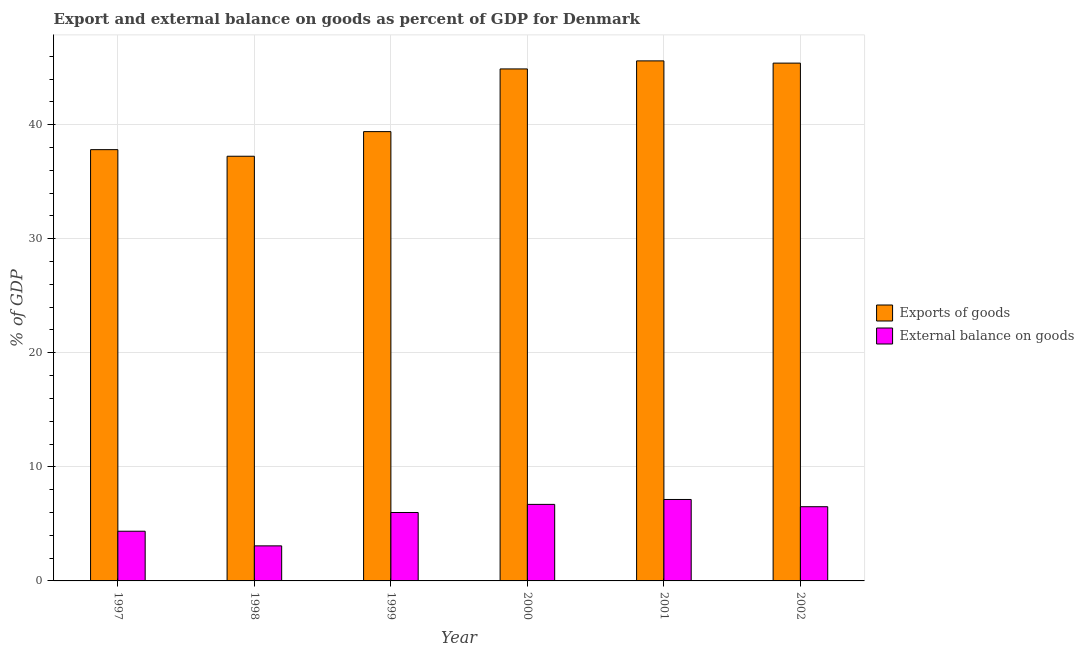How many different coloured bars are there?
Give a very brief answer. 2. How many groups of bars are there?
Make the answer very short. 6. Are the number of bars on each tick of the X-axis equal?
Your answer should be compact. Yes. How many bars are there on the 3rd tick from the left?
Give a very brief answer. 2. How many bars are there on the 2nd tick from the right?
Provide a succinct answer. 2. What is the external balance on goods as percentage of gdp in 1999?
Provide a short and direct response. 6. Across all years, what is the maximum export of goods as percentage of gdp?
Make the answer very short. 45.6. Across all years, what is the minimum external balance on goods as percentage of gdp?
Your answer should be compact. 3.07. In which year was the external balance on goods as percentage of gdp maximum?
Offer a terse response. 2001. What is the total external balance on goods as percentage of gdp in the graph?
Ensure brevity in your answer.  33.79. What is the difference between the export of goods as percentage of gdp in 1999 and that in 2001?
Make the answer very short. -6.2. What is the difference between the external balance on goods as percentage of gdp in 1997 and the export of goods as percentage of gdp in 1999?
Provide a short and direct response. -1.64. What is the average export of goods as percentage of gdp per year?
Offer a very short reply. 41.72. In the year 2001, what is the difference between the external balance on goods as percentage of gdp and export of goods as percentage of gdp?
Your response must be concise. 0. What is the ratio of the export of goods as percentage of gdp in 1997 to that in 1998?
Your answer should be compact. 1.02. Is the export of goods as percentage of gdp in 1997 less than that in 1998?
Provide a succinct answer. No. Is the difference between the external balance on goods as percentage of gdp in 1997 and 1998 greater than the difference between the export of goods as percentage of gdp in 1997 and 1998?
Keep it short and to the point. No. What is the difference between the highest and the second highest export of goods as percentage of gdp?
Offer a very short reply. 0.2. What is the difference between the highest and the lowest external balance on goods as percentage of gdp?
Offer a terse response. 4.07. What does the 1st bar from the left in 2001 represents?
Offer a terse response. Exports of goods. What does the 1st bar from the right in 2002 represents?
Make the answer very short. External balance on goods. How many bars are there?
Your answer should be very brief. 12. Are all the bars in the graph horizontal?
Your response must be concise. No. Does the graph contain any zero values?
Provide a succinct answer. No. How many legend labels are there?
Your answer should be very brief. 2. How are the legend labels stacked?
Offer a terse response. Vertical. What is the title of the graph?
Give a very brief answer. Export and external balance on goods as percent of GDP for Denmark. Does "Methane emissions" appear as one of the legend labels in the graph?
Provide a short and direct response. No. What is the label or title of the Y-axis?
Keep it short and to the point. % of GDP. What is the % of GDP of Exports of goods in 1997?
Provide a succinct answer. 37.81. What is the % of GDP in External balance on goods in 1997?
Ensure brevity in your answer.  4.36. What is the % of GDP of Exports of goods in 1998?
Make the answer very short. 37.23. What is the % of GDP of External balance on goods in 1998?
Provide a succinct answer. 3.07. What is the % of GDP of Exports of goods in 1999?
Offer a very short reply. 39.39. What is the % of GDP in External balance on goods in 1999?
Offer a very short reply. 6. What is the % of GDP in Exports of goods in 2000?
Ensure brevity in your answer.  44.89. What is the % of GDP in External balance on goods in 2000?
Offer a terse response. 6.71. What is the % of GDP in Exports of goods in 2001?
Give a very brief answer. 45.6. What is the % of GDP of External balance on goods in 2001?
Your answer should be compact. 7.14. What is the % of GDP in Exports of goods in 2002?
Give a very brief answer. 45.4. What is the % of GDP in External balance on goods in 2002?
Offer a very short reply. 6.51. Across all years, what is the maximum % of GDP in Exports of goods?
Provide a succinct answer. 45.6. Across all years, what is the maximum % of GDP of External balance on goods?
Give a very brief answer. 7.14. Across all years, what is the minimum % of GDP of Exports of goods?
Offer a very short reply. 37.23. Across all years, what is the minimum % of GDP in External balance on goods?
Provide a succinct answer. 3.07. What is the total % of GDP in Exports of goods in the graph?
Your answer should be compact. 250.32. What is the total % of GDP in External balance on goods in the graph?
Make the answer very short. 33.79. What is the difference between the % of GDP in Exports of goods in 1997 and that in 1998?
Your answer should be compact. 0.58. What is the difference between the % of GDP in External balance on goods in 1997 and that in 1998?
Offer a terse response. 1.28. What is the difference between the % of GDP of Exports of goods in 1997 and that in 1999?
Ensure brevity in your answer.  -1.58. What is the difference between the % of GDP in External balance on goods in 1997 and that in 1999?
Give a very brief answer. -1.64. What is the difference between the % of GDP in Exports of goods in 1997 and that in 2000?
Your answer should be very brief. -7.08. What is the difference between the % of GDP in External balance on goods in 1997 and that in 2000?
Your response must be concise. -2.35. What is the difference between the % of GDP in Exports of goods in 1997 and that in 2001?
Your answer should be very brief. -7.78. What is the difference between the % of GDP of External balance on goods in 1997 and that in 2001?
Your answer should be compact. -2.78. What is the difference between the % of GDP in Exports of goods in 1997 and that in 2002?
Offer a terse response. -7.59. What is the difference between the % of GDP of External balance on goods in 1997 and that in 2002?
Offer a very short reply. -2.15. What is the difference between the % of GDP of Exports of goods in 1998 and that in 1999?
Keep it short and to the point. -2.16. What is the difference between the % of GDP in External balance on goods in 1998 and that in 1999?
Give a very brief answer. -2.93. What is the difference between the % of GDP of Exports of goods in 1998 and that in 2000?
Offer a terse response. -7.66. What is the difference between the % of GDP of External balance on goods in 1998 and that in 2000?
Offer a terse response. -3.64. What is the difference between the % of GDP of Exports of goods in 1998 and that in 2001?
Provide a succinct answer. -8.36. What is the difference between the % of GDP of External balance on goods in 1998 and that in 2001?
Your answer should be very brief. -4.07. What is the difference between the % of GDP of Exports of goods in 1998 and that in 2002?
Ensure brevity in your answer.  -8.16. What is the difference between the % of GDP of External balance on goods in 1998 and that in 2002?
Offer a terse response. -3.43. What is the difference between the % of GDP in Exports of goods in 1999 and that in 2000?
Provide a short and direct response. -5.5. What is the difference between the % of GDP of External balance on goods in 1999 and that in 2000?
Provide a short and direct response. -0.71. What is the difference between the % of GDP in Exports of goods in 1999 and that in 2001?
Ensure brevity in your answer.  -6.2. What is the difference between the % of GDP in External balance on goods in 1999 and that in 2001?
Give a very brief answer. -1.14. What is the difference between the % of GDP in Exports of goods in 1999 and that in 2002?
Keep it short and to the point. -6. What is the difference between the % of GDP of External balance on goods in 1999 and that in 2002?
Offer a very short reply. -0.51. What is the difference between the % of GDP of Exports of goods in 2000 and that in 2001?
Keep it short and to the point. -0.71. What is the difference between the % of GDP of External balance on goods in 2000 and that in 2001?
Your answer should be very brief. -0.43. What is the difference between the % of GDP of Exports of goods in 2000 and that in 2002?
Provide a short and direct response. -0.51. What is the difference between the % of GDP in External balance on goods in 2000 and that in 2002?
Ensure brevity in your answer.  0.2. What is the difference between the % of GDP in Exports of goods in 2001 and that in 2002?
Make the answer very short. 0.2. What is the difference between the % of GDP in External balance on goods in 2001 and that in 2002?
Your answer should be very brief. 0.63. What is the difference between the % of GDP in Exports of goods in 1997 and the % of GDP in External balance on goods in 1998?
Offer a very short reply. 34.74. What is the difference between the % of GDP in Exports of goods in 1997 and the % of GDP in External balance on goods in 1999?
Keep it short and to the point. 31.81. What is the difference between the % of GDP in Exports of goods in 1997 and the % of GDP in External balance on goods in 2000?
Your answer should be compact. 31.1. What is the difference between the % of GDP in Exports of goods in 1997 and the % of GDP in External balance on goods in 2001?
Give a very brief answer. 30.67. What is the difference between the % of GDP of Exports of goods in 1997 and the % of GDP of External balance on goods in 2002?
Provide a short and direct response. 31.31. What is the difference between the % of GDP in Exports of goods in 1998 and the % of GDP in External balance on goods in 1999?
Provide a short and direct response. 31.23. What is the difference between the % of GDP in Exports of goods in 1998 and the % of GDP in External balance on goods in 2000?
Offer a very short reply. 30.52. What is the difference between the % of GDP in Exports of goods in 1998 and the % of GDP in External balance on goods in 2001?
Provide a short and direct response. 30.09. What is the difference between the % of GDP in Exports of goods in 1998 and the % of GDP in External balance on goods in 2002?
Offer a very short reply. 30.73. What is the difference between the % of GDP of Exports of goods in 1999 and the % of GDP of External balance on goods in 2000?
Your answer should be very brief. 32.68. What is the difference between the % of GDP in Exports of goods in 1999 and the % of GDP in External balance on goods in 2001?
Ensure brevity in your answer.  32.25. What is the difference between the % of GDP of Exports of goods in 1999 and the % of GDP of External balance on goods in 2002?
Provide a succinct answer. 32.89. What is the difference between the % of GDP in Exports of goods in 2000 and the % of GDP in External balance on goods in 2001?
Your answer should be compact. 37.75. What is the difference between the % of GDP in Exports of goods in 2000 and the % of GDP in External balance on goods in 2002?
Keep it short and to the point. 38.38. What is the difference between the % of GDP of Exports of goods in 2001 and the % of GDP of External balance on goods in 2002?
Offer a very short reply. 39.09. What is the average % of GDP in Exports of goods per year?
Give a very brief answer. 41.72. What is the average % of GDP of External balance on goods per year?
Your answer should be very brief. 5.63. In the year 1997, what is the difference between the % of GDP of Exports of goods and % of GDP of External balance on goods?
Make the answer very short. 33.45. In the year 1998, what is the difference between the % of GDP of Exports of goods and % of GDP of External balance on goods?
Ensure brevity in your answer.  34.16. In the year 1999, what is the difference between the % of GDP of Exports of goods and % of GDP of External balance on goods?
Keep it short and to the point. 33.39. In the year 2000, what is the difference between the % of GDP in Exports of goods and % of GDP in External balance on goods?
Keep it short and to the point. 38.18. In the year 2001, what is the difference between the % of GDP in Exports of goods and % of GDP in External balance on goods?
Keep it short and to the point. 38.45. In the year 2002, what is the difference between the % of GDP of Exports of goods and % of GDP of External balance on goods?
Make the answer very short. 38.89. What is the ratio of the % of GDP of Exports of goods in 1997 to that in 1998?
Your answer should be compact. 1.02. What is the ratio of the % of GDP in External balance on goods in 1997 to that in 1998?
Your answer should be very brief. 1.42. What is the ratio of the % of GDP of Exports of goods in 1997 to that in 1999?
Your answer should be compact. 0.96. What is the ratio of the % of GDP in External balance on goods in 1997 to that in 1999?
Keep it short and to the point. 0.73. What is the ratio of the % of GDP of Exports of goods in 1997 to that in 2000?
Your answer should be compact. 0.84. What is the ratio of the % of GDP of External balance on goods in 1997 to that in 2000?
Give a very brief answer. 0.65. What is the ratio of the % of GDP in Exports of goods in 1997 to that in 2001?
Your response must be concise. 0.83. What is the ratio of the % of GDP of External balance on goods in 1997 to that in 2001?
Your response must be concise. 0.61. What is the ratio of the % of GDP of Exports of goods in 1997 to that in 2002?
Give a very brief answer. 0.83. What is the ratio of the % of GDP in External balance on goods in 1997 to that in 2002?
Make the answer very short. 0.67. What is the ratio of the % of GDP in Exports of goods in 1998 to that in 1999?
Give a very brief answer. 0.95. What is the ratio of the % of GDP of External balance on goods in 1998 to that in 1999?
Keep it short and to the point. 0.51. What is the ratio of the % of GDP in Exports of goods in 1998 to that in 2000?
Offer a terse response. 0.83. What is the ratio of the % of GDP of External balance on goods in 1998 to that in 2000?
Keep it short and to the point. 0.46. What is the ratio of the % of GDP of Exports of goods in 1998 to that in 2001?
Ensure brevity in your answer.  0.82. What is the ratio of the % of GDP of External balance on goods in 1998 to that in 2001?
Your answer should be compact. 0.43. What is the ratio of the % of GDP in Exports of goods in 1998 to that in 2002?
Offer a very short reply. 0.82. What is the ratio of the % of GDP in External balance on goods in 1998 to that in 2002?
Provide a succinct answer. 0.47. What is the ratio of the % of GDP of Exports of goods in 1999 to that in 2000?
Give a very brief answer. 0.88. What is the ratio of the % of GDP of External balance on goods in 1999 to that in 2000?
Your response must be concise. 0.89. What is the ratio of the % of GDP in Exports of goods in 1999 to that in 2001?
Provide a short and direct response. 0.86. What is the ratio of the % of GDP of External balance on goods in 1999 to that in 2001?
Your response must be concise. 0.84. What is the ratio of the % of GDP of Exports of goods in 1999 to that in 2002?
Offer a very short reply. 0.87. What is the ratio of the % of GDP in External balance on goods in 1999 to that in 2002?
Make the answer very short. 0.92. What is the ratio of the % of GDP of Exports of goods in 2000 to that in 2001?
Provide a short and direct response. 0.98. What is the ratio of the % of GDP of External balance on goods in 2000 to that in 2001?
Provide a short and direct response. 0.94. What is the ratio of the % of GDP in External balance on goods in 2000 to that in 2002?
Make the answer very short. 1.03. What is the ratio of the % of GDP in Exports of goods in 2001 to that in 2002?
Your answer should be compact. 1. What is the ratio of the % of GDP of External balance on goods in 2001 to that in 2002?
Ensure brevity in your answer.  1.1. What is the difference between the highest and the second highest % of GDP of Exports of goods?
Provide a succinct answer. 0.2. What is the difference between the highest and the second highest % of GDP of External balance on goods?
Provide a succinct answer. 0.43. What is the difference between the highest and the lowest % of GDP of Exports of goods?
Ensure brevity in your answer.  8.36. What is the difference between the highest and the lowest % of GDP in External balance on goods?
Ensure brevity in your answer.  4.07. 